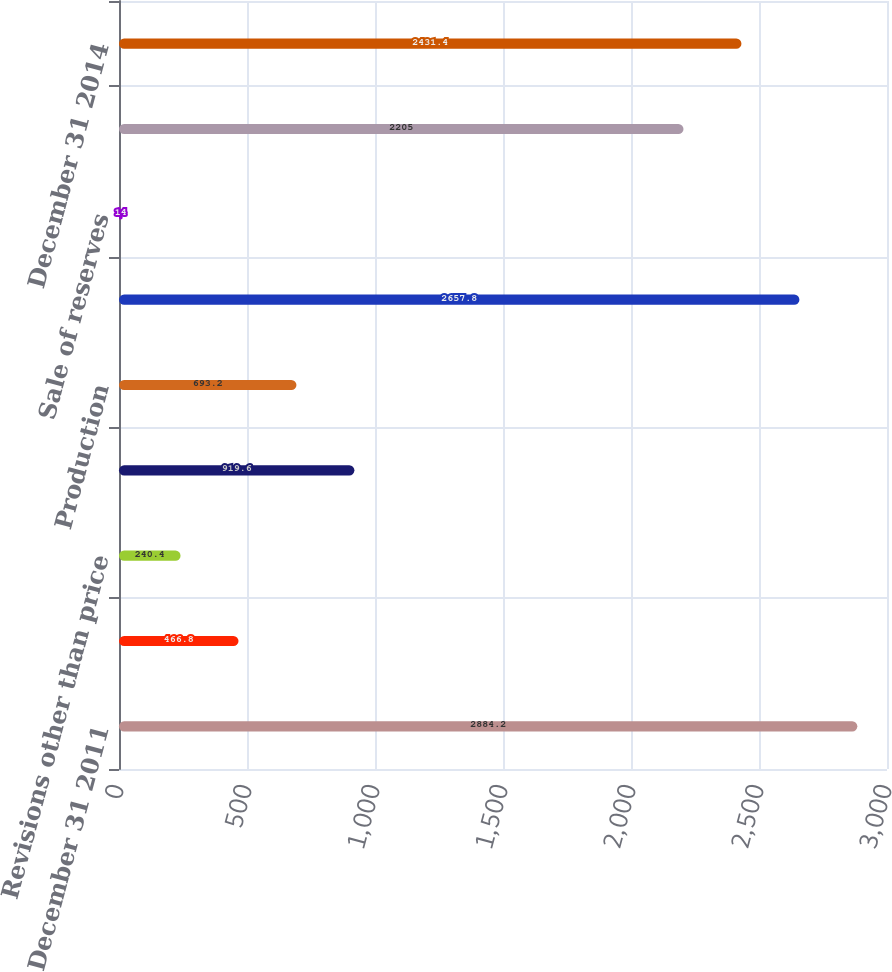Convert chart. <chart><loc_0><loc_0><loc_500><loc_500><bar_chart><fcel>December 31 2011<fcel>Revisions due to prices<fcel>Revisions other than price<fcel>Extensions and discoveries<fcel>Production<fcel>December 31 2012<fcel>Sale of reserves<fcel>December 31 2013<fcel>December 31 2014<nl><fcel>2884.2<fcel>466.8<fcel>240.4<fcel>919.6<fcel>693.2<fcel>2657.8<fcel>14<fcel>2205<fcel>2431.4<nl></chart> 